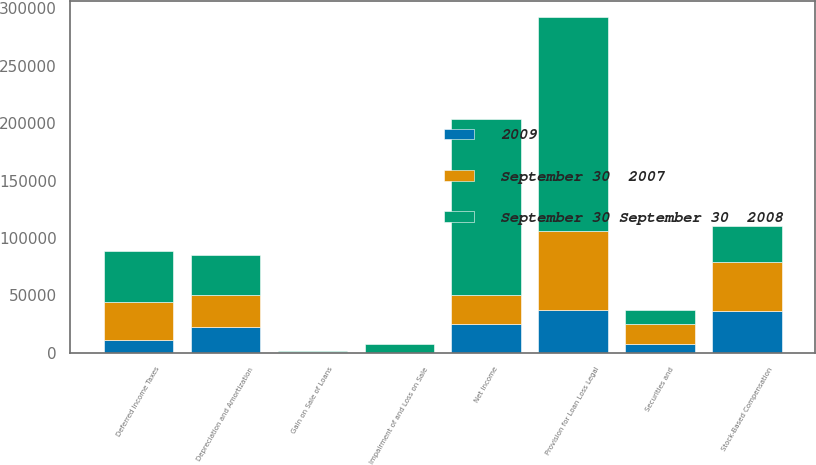Convert chart to OTSL. <chart><loc_0><loc_0><loc_500><loc_500><stacked_bar_chart><ecel><fcel>Net Income<fcel>Depreciation and Amortization<fcel>Deferred Income Taxes<fcel>Securities and<fcel>Impairment of and Loss on Sale<fcel>Gain on Sale of Loans<fcel>Provision for Loan Loss Legal<fcel>Stock-Based Compensation<nl><fcel>September 30 September 30  2008<fcel>152750<fcel>34563<fcel>44671<fcel>11863<fcel>7374<fcel>676<fcel>186376<fcel>31746<nl><fcel>September 30  2007<fcel>25306.5<fcel>27982<fcel>32422<fcel>17404<fcel>36<fcel>364<fcel>68764<fcel>42127<nl><fcel>2009<fcel>25306.5<fcel>22631<fcel>11515<fcel>7914<fcel>20<fcel>518<fcel>37138<fcel>36563<nl></chart> 